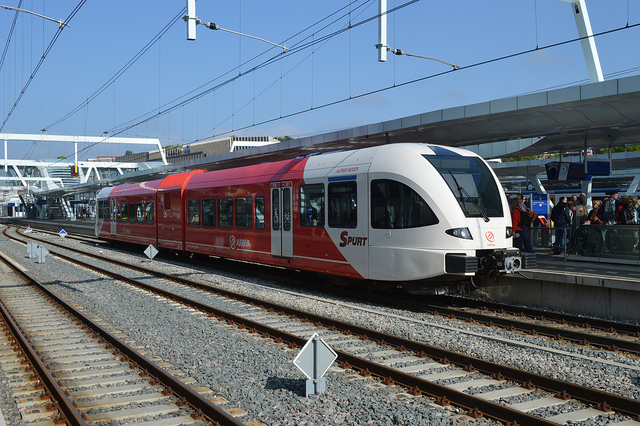Extract all visible text content from this image. SPURT 